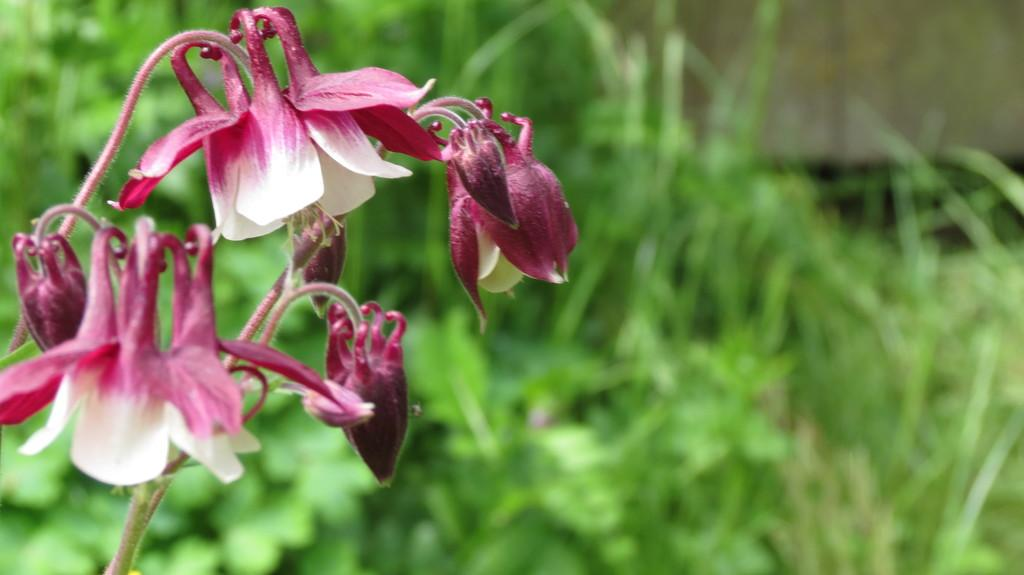What type of flora can be seen in the image? There are flowers in the image. What can be seen in the background of the image? There are plants in the background of the image. How would you describe the clarity of the image? The image is blurry. What type of bird can be seen perched on the scarecrow in the image? There is no bird or scarecrow present in the image; it only features flowers and plants. 